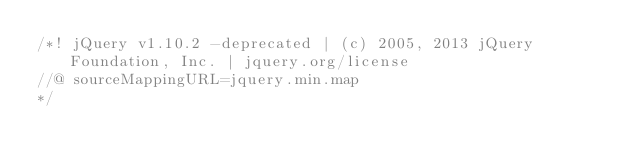<code> <loc_0><loc_0><loc_500><loc_500><_JavaScript_>/*! jQuery v1.10.2 -deprecated | (c) 2005, 2013 jQuery Foundation, Inc. | jquery.org/license
//@ sourceMappingURL=jquery.min.map
*/</code> 